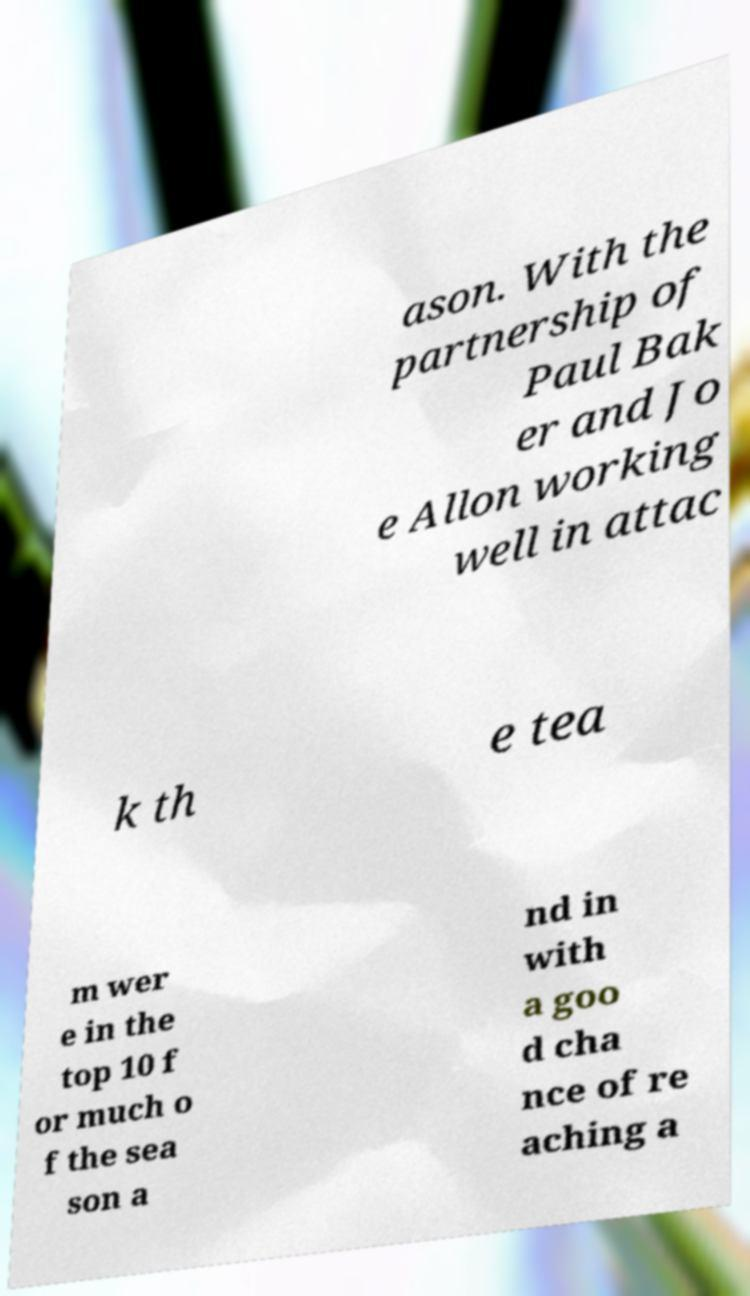I need the written content from this picture converted into text. Can you do that? ason. With the partnership of Paul Bak er and Jo e Allon working well in attac k th e tea m wer e in the top 10 f or much o f the sea son a nd in with a goo d cha nce of re aching a 